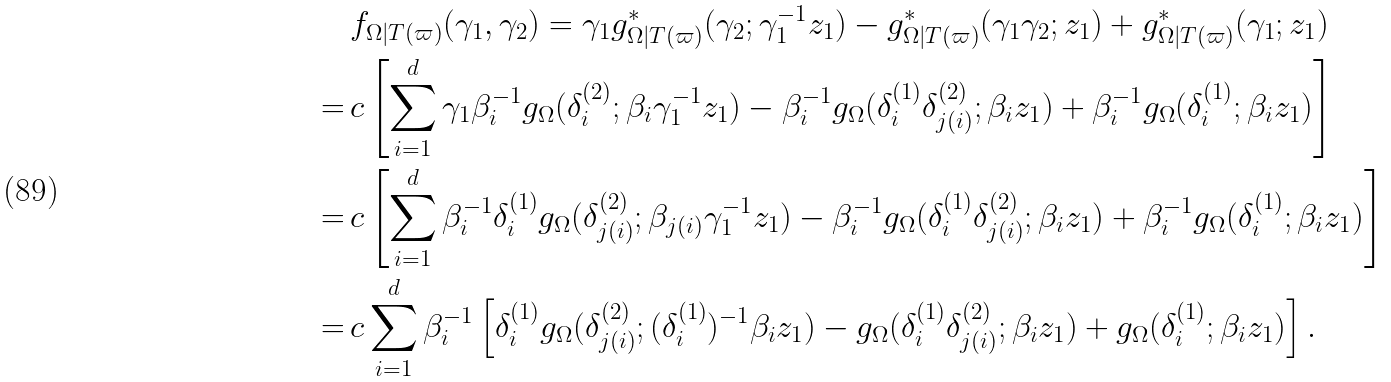<formula> <loc_0><loc_0><loc_500><loc_500>& f _ { \Omega | T ( \varpi ) } ( \gamma _ { 1 } , \gamma _ { 2 } ) = \gamma _ { 1 } g _ { \Omega | T ( \varpi ) } ^ { \ast } ( \gamma _ { 2 } ; \gamma _ { 1 } ^ { - 1 } z _ { 1 } ) - g _ { \Omega | T ( \varpi ) } ^ { \ast } ( \gamma _ { 1 } \gamma _ { 2 } ; z _ { 1 } ) + g _ { \Omega | T ( \varpi ) } ^ { \ast } ( \gamma _ { 1 } ; z _ { 1 } ) \\ = \, & c \left [ \sum _ { i = 1 } ^ { d } \gamma _ { 1 } \beta _ { i } ^ { - 1 } g _ { \Omega } ( \delta _ { i } ^ { ( 2 ) } ; \beta _ { i } \gamma _ { 1 } ^ { - 1 } z _ { 1 } ) - \beta _ { i } ^ { - 1 } g _ { \Omega } ( \delta _ { i } ^ { ( 1 ) } \delta _ { j ( i ) } ^ { ( 2 ) } ; \beta _ { i } z _ { 1 } ) + \beta _ { i } ^ { - 1 } g _ { \Omega } ( \delta _ { i } ^ { ( 1 ) } ; \beta _ { i } z _ { 1 } ) \right ] \\ = \, & c \left [ \sum _ { i = 1 } ^ { d } \beta _ { i } ^ { - 1 } \delta _ { i } ^ { ( 1 ) } g _ { \Omega } ( \delta _ { j ( i ) } ^ { ( 2 ) } ; \beta _ { j ( i ) } \gamma _ { 1 } ^ { - 1 } z _ { 1 } ) - \beta _ { i } ^ { - 1 } g _ { \Omega } ( \delta _ { i } ^ { ( 1 ) } \delta _ { j ( i ) } ^ { ( 2 ) } ; \beta _ { i } z _ { 1 } ) + \beta _ { i } ^ { - 1 } g _ { \Omega } ( \delta _ { i } ^ { ( 1 ) } ; \beta _ { i } z _ { 1 } ) \right ] \\ = \, & c \sum _ { i = 1 } ^ { d } \beta _ { i } ^ { - 1 } \left [ \delta _ { i } ^ { ( 1 ) } g _ { \Omega } ( \delta _ { j ( i ) } ^ { ( 2 ) } ; ( \delta _ { i } ^ { ( 1 ) } ) ^ { - 1 } \beta _ { i } z _ { 1 } ) - g _ { \Omega } ( \delta _ { i } ^ { ( 1 ) } \delta _ { j ( i ) } ^ { ( 2 ) } ; \beta _ { i } z _ { 1 } ) + g _ { \Omega } ( \delta _ { i } ^ { ( 1 ) } ; \beta _ { i } z _ { 1 } ) \right ] .</formula> 